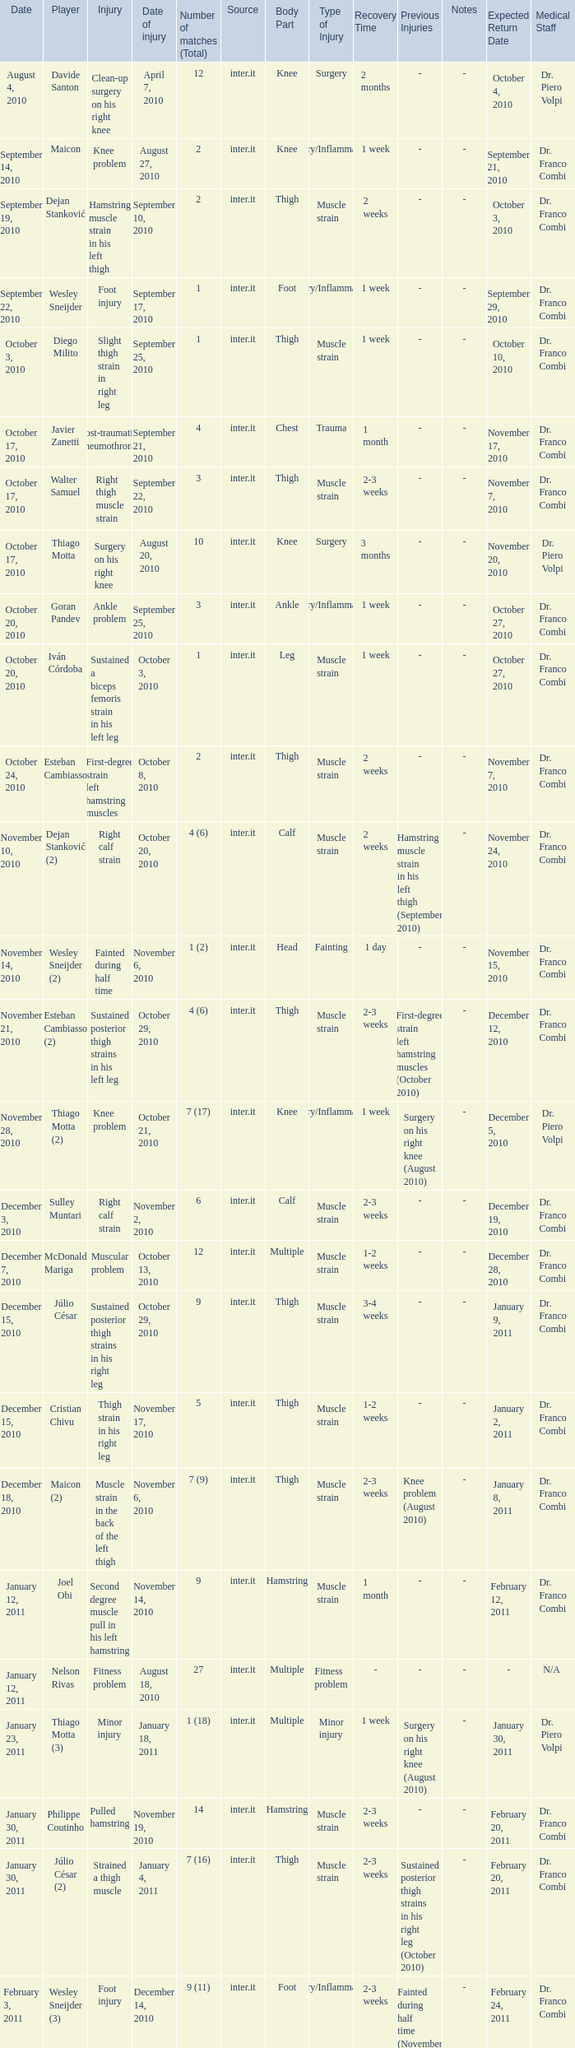How many times was the date october 3, 2010? 1.0. 